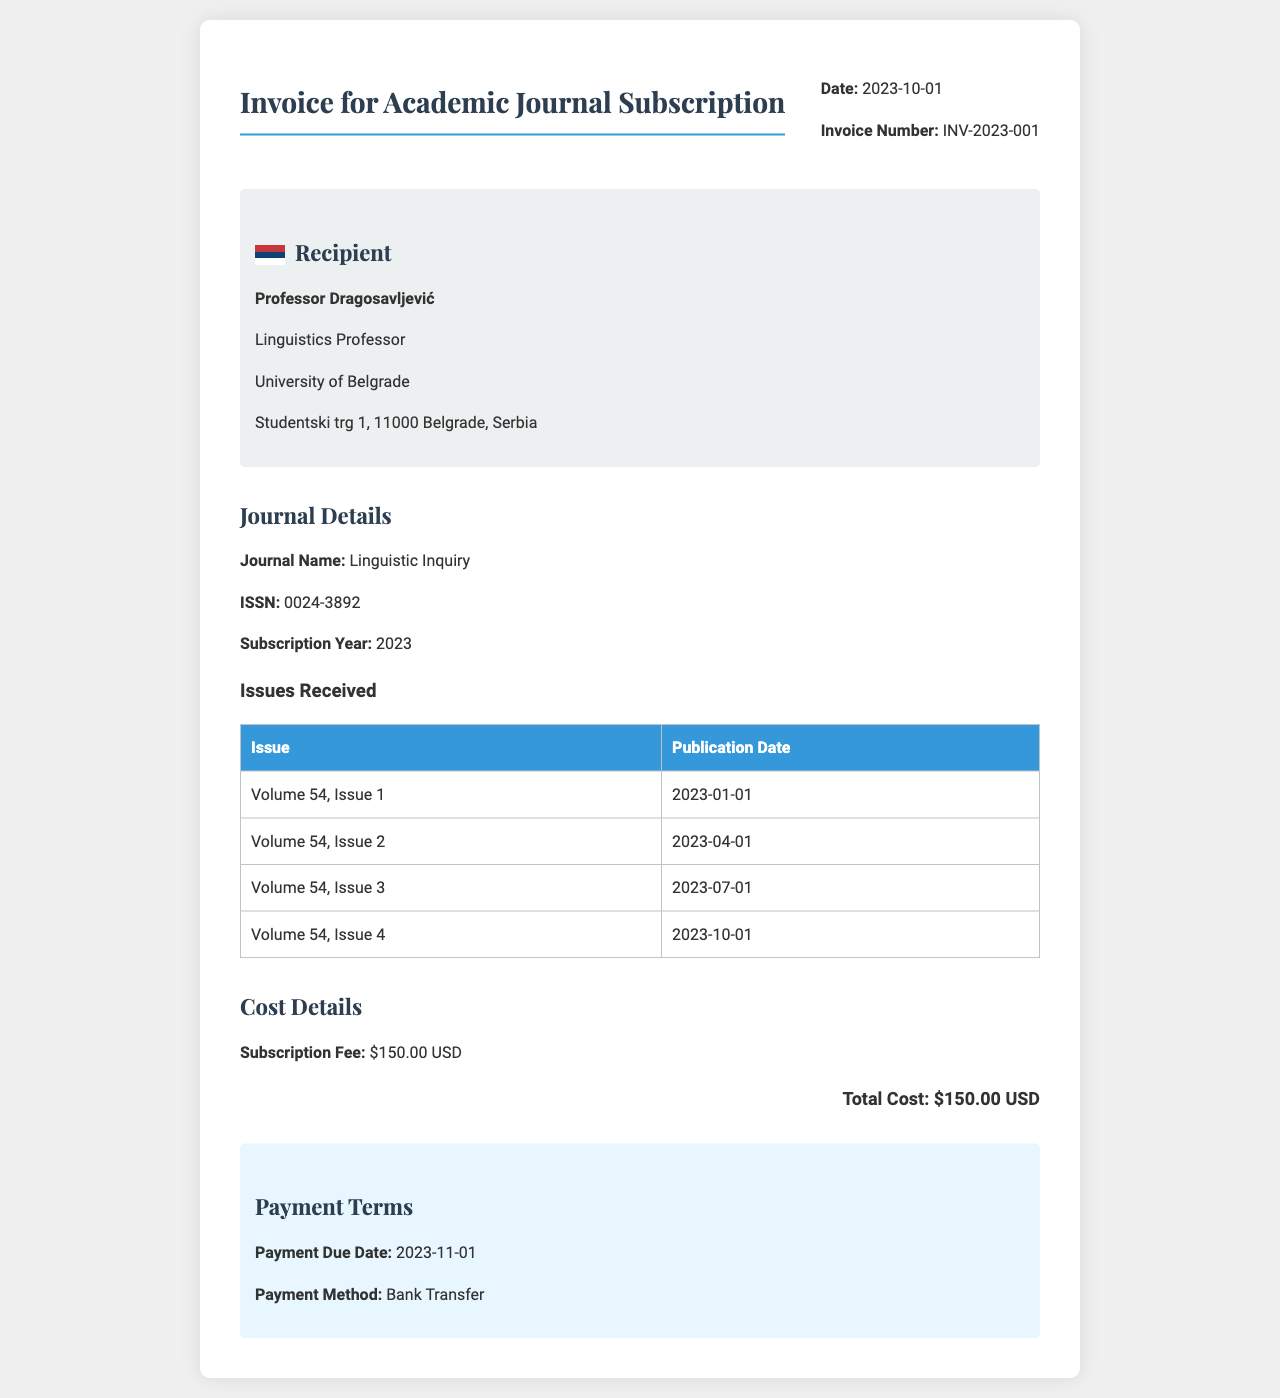What is the invoice number? The invoice number is located within the header section of the document.
Answer: INV-2023-001 What is the subscription fee? The subscription fee is explicitly stated in the cost details section of the document.
Answer: $150.00 USD How many issues were received in 2023? This information can be found under the Issues Received table, which lists all the issues.
Answer: 4 What is the publication date of Volume 54, Issue 3? The publication date is listed in the table under the Issues Received section.
Answer: 2023-07-01 What is the payment due date? The payment due date is mentioned in the payment terms section of the document.
Answer: 2023-11-01 What journal name is listed on the invoice? The journal name is specified in the journal details section.
Answer: Linguistic Inquiry What is the total cost for the subscription? The total cost for the subscription is indicated in the cost details section, calculated from the subscription fee.
Answer: $150.00 USD What method of payment is specified in the document? This information is found in the payment terms section under the method of payment.
Answer: Bank Transfer 